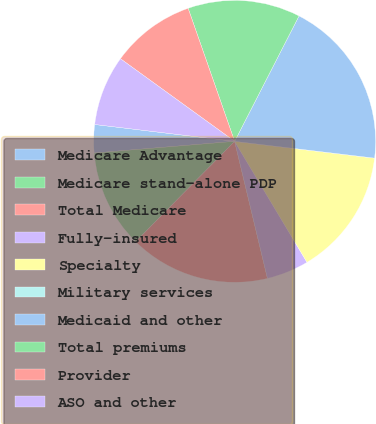Convert chart to OTSL. <chart><loc_0><loc_0><loc_500><loc_500><pie_chart><fcel>Medicare Advantage<fcel>Medicare stand-alone PDP<fcel>Total Medicare<fcel>Fully-insured<fcel>Specialty<fcel>Military services<fcel>Medicaid and other<fcel>Total premiums<fcel>Provider<fcel>ASO and other<nl><fcel>3.23%<fcel>11.29%<fcel>16.13%<fcel>4.84%<fcel>14.52%<fcel>0.0%<fcel>19.35%<fcel>12.9%<fcel>9.68%<fcel>8.06%<nl></chart> 